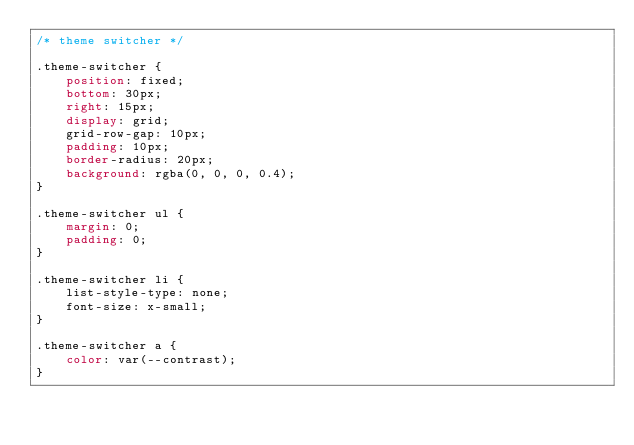<code> <loc_0><loc_0><loc_500><loc_500><_CSS_>/* theme switcher */

.theme-switcher {
    position: fixed;
    bottom: 30px;
    right: 15px;
    display: grid;
    grid-row-gap: 10px;
    padding: 10px;
    border-radius: 20px;
    background: rgba(0, 0, 0, 0.4);
}
  
.theme-switcher ul {
    margin: 0;
    padding: 0;
}
  
.theme-switcher li {
    list-style-type: none;
    font-size: x-small;
}
  
.theme-switcher a {
    color: var(--contrast);
}</code> 